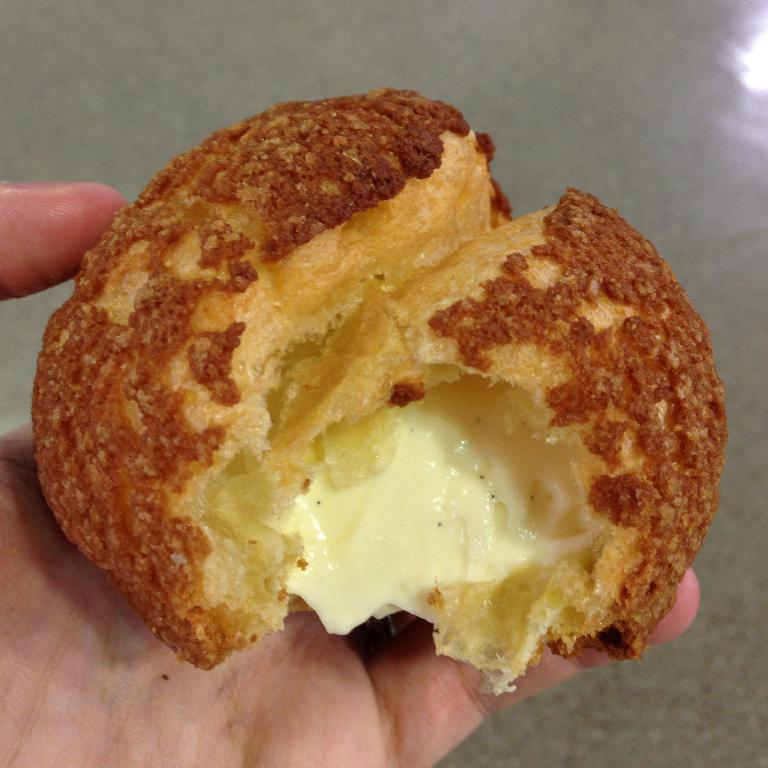What is the human hand holding in the image? The human hand is holding a food item, which is cream. Can you describe the texture or appearance of the food item? The food item is cream, which typically has a smooth and creamy texture. What can be seen in the background of the image? There is a floor visible in the background of the image. What time is depicted in the image? The image does not depict a specific time, as it only shows a human hand holding cream and a floor in the background. Can you see a blade in the image? There is no blade present in the image. 